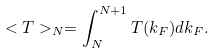<formula> <loc_0><loc_0><loc_500><loc_500>< T > _ { N } = \int _ { N } ^ { N + 1 } T ( k _ { F } ) d k _ { F } .</formula> 